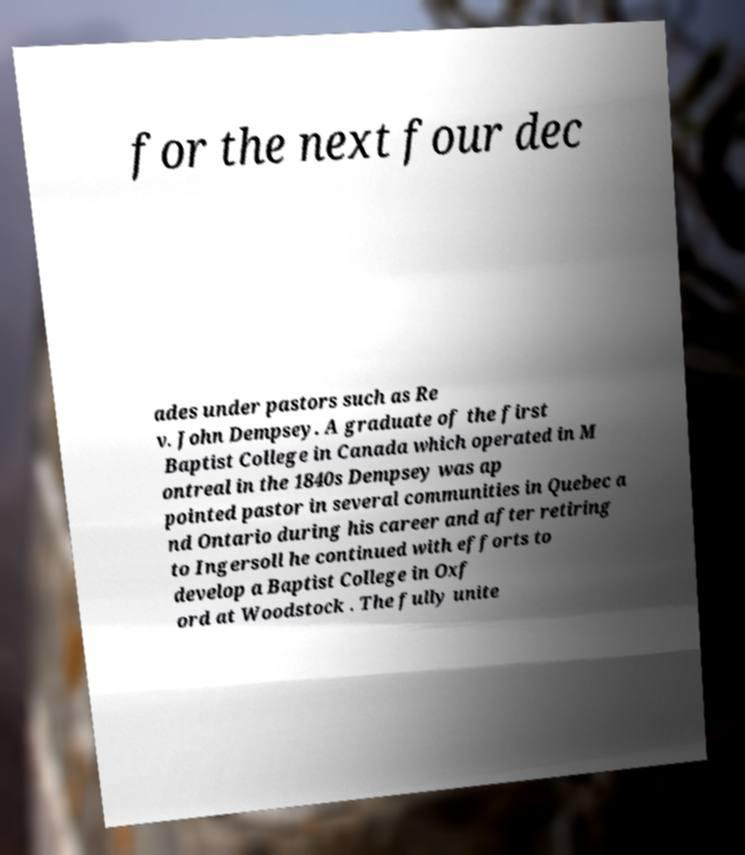There's text embedded in this image that I need extracted. Can you transcribe it verbatim? for the next four dec ades under pastors such as Re v. John Dempsey. A graduate of the first Baptist College in Canada which operated in M ontreal in the 1840s Dempsey was ap pointed pastor in several communities in Quebec a nd Ontario during his career and after retiring to Ingersoll he continued with efforts to develop a Baptist College in Oxf ord at Woodstock . The fully unite 